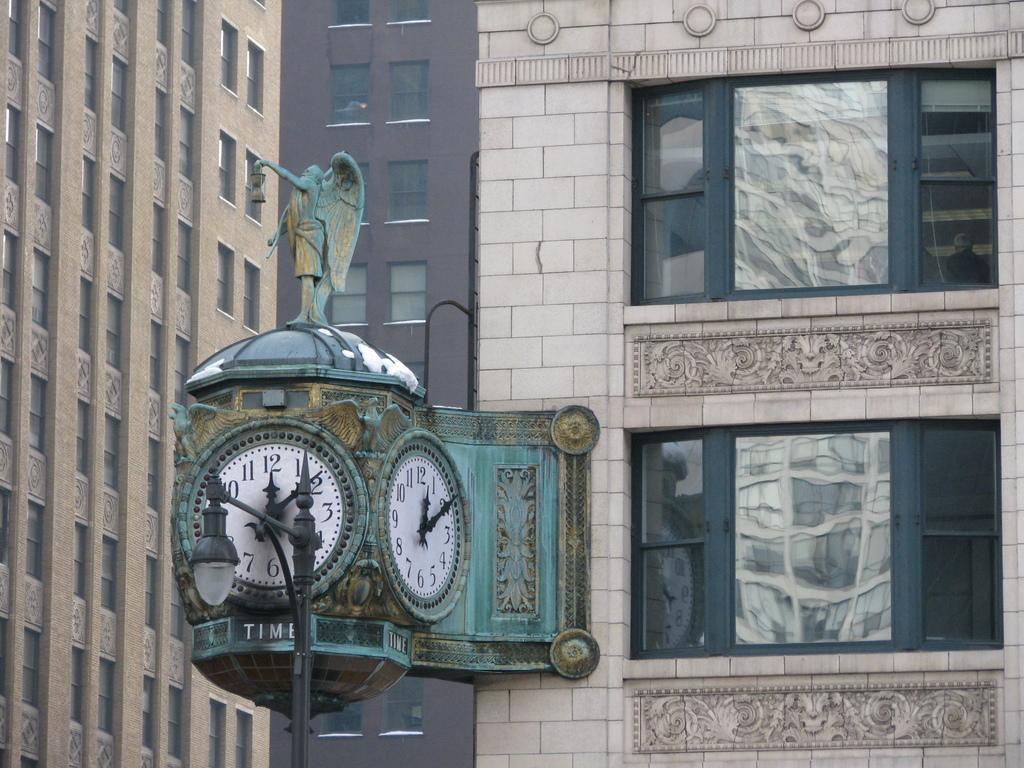Please provide a concise description of this image. In the picture we can see a sculpture with two clocks to it and sculpture person idol standing with wings on top of it, and behind it we can see buildings with windows and glasses to it. 